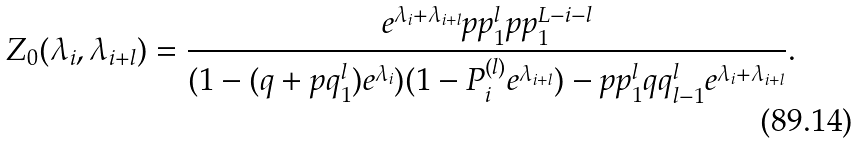<formula> <loc_0><loc_0><loc_500><loc_500>Z _ { 0 } ( \lambda _ { i } , \lambda _ { i + l } ) = \frac { e ^ { \lambda _ { i } + \lambda _ { i + l } } p p _ { 1 } ^ { l } p p _ { 1 } ^ { L - i - l } } { ( 1 - ( q + p q _ { 1 } ^ { l } ) e ^ { \lambda _ { i } } ) ( 1 - P _ { i } ^ { ( l ) } e ^ { \lambda _ { i + l } } ) - p p _ { 1 } ^ { l } q q _ { l - 1 } ^ { l } e ^ { \lambda _ { i } + \lambda _ { i + l } } } .</formula> 